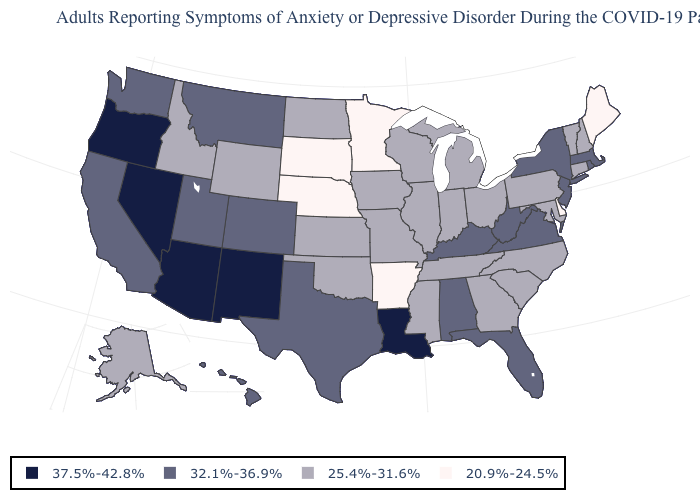Does South Dakota have the lowest value in the USA?
Short answer required. Yes. What is the value of Ohio?
Quick response, please. 25.4%-31.6%. Among the states that border Wyoming , does Colorado have the highest value?
Keep it brief. Yes. Which states hav the highest value in the Northeast?
Write a very short answer. Massachusetts, New Jersey, New York, Rhode Island. What is the lowest value in the USA?
Answer briefly. 20.9%-24.5%. What is the value of Arizona?
Short answer required. 37.5%-42.8%. What is the value of South Carolina?
Give a very brief answer. 25.4%-31.6%. What is the highest value in the MidWest ?
Quick response, please. 25.4%-31.6%. What is the lowest value in states that border Maine?
Concise answer only. 25.4%-31.6%. Does Colorado have the lowest value in the USA?
Short answer required. No. Which states hav the highest value in the South?
Short answer required. Louisiana. Name the states that have a value in the range 32.1%-36.9%?
Give a very brief answer. Alabama, California, Colorado, Florida, Hawaii, Kentucky, Massachusetts, Montana, New Jersey, New York, Rhode Island, Texas, Utah, Virginia, Washington, West Virginia. What is the highest value in the USA?
Answer briefly. 37.5%-42.8%. Does Michigan have the same value as West Virginia?
Give a very brief answer. No. What is the value of Tennessee?
Answer briefly. 25.4%-31.6%. 